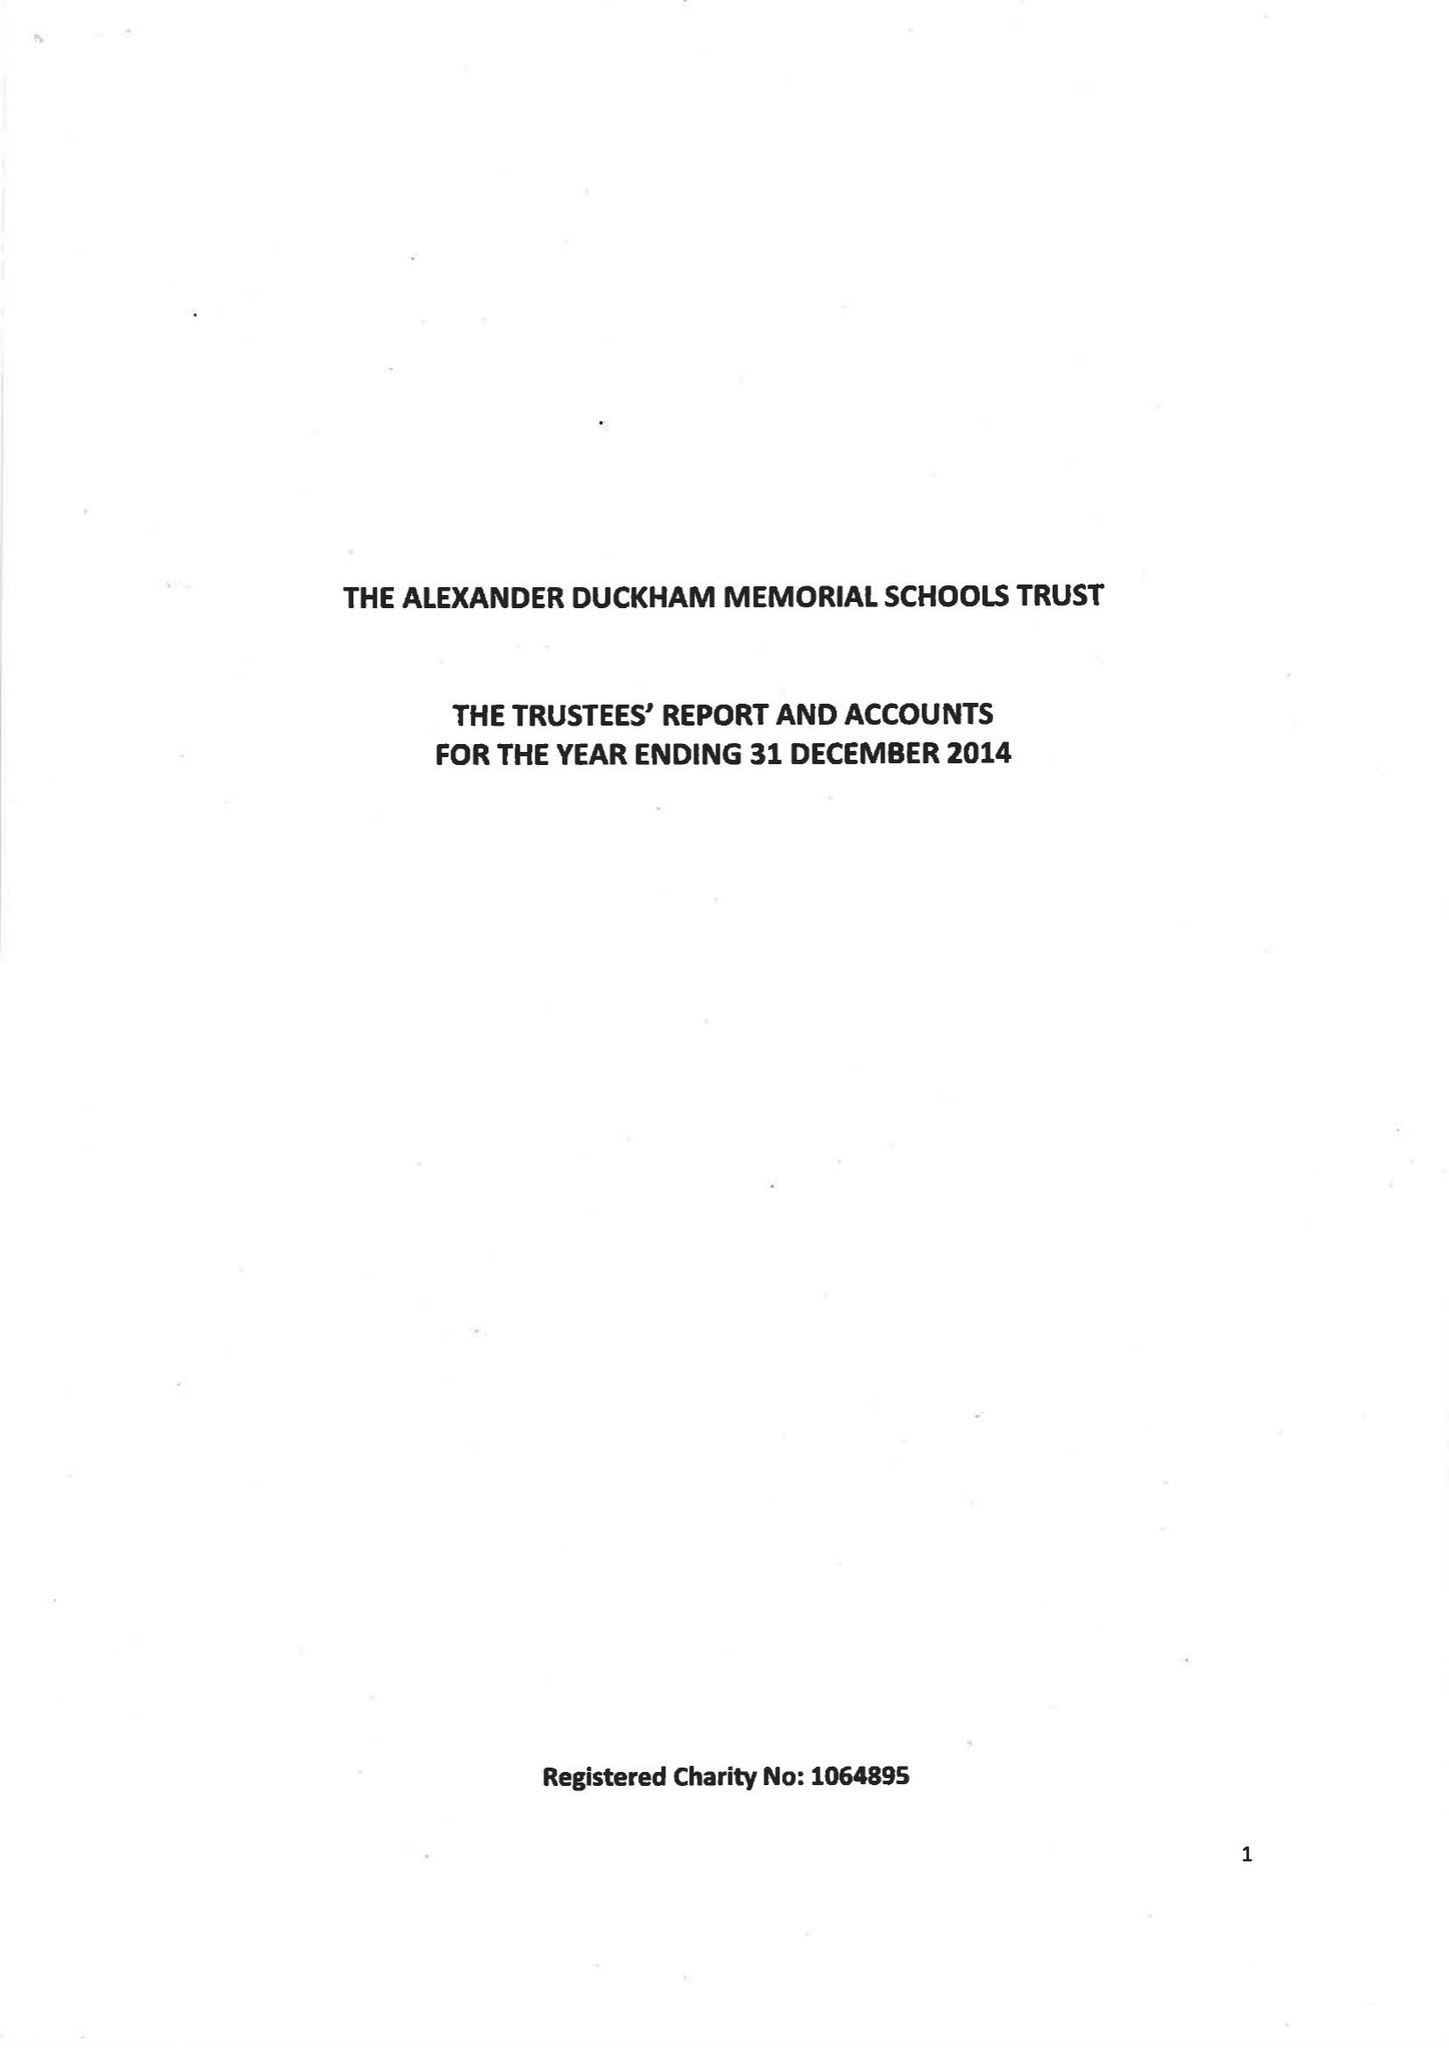What is the value for the spending_annually_in_british_pounds?
Answer the question using a single word or phrase. 63238.00 